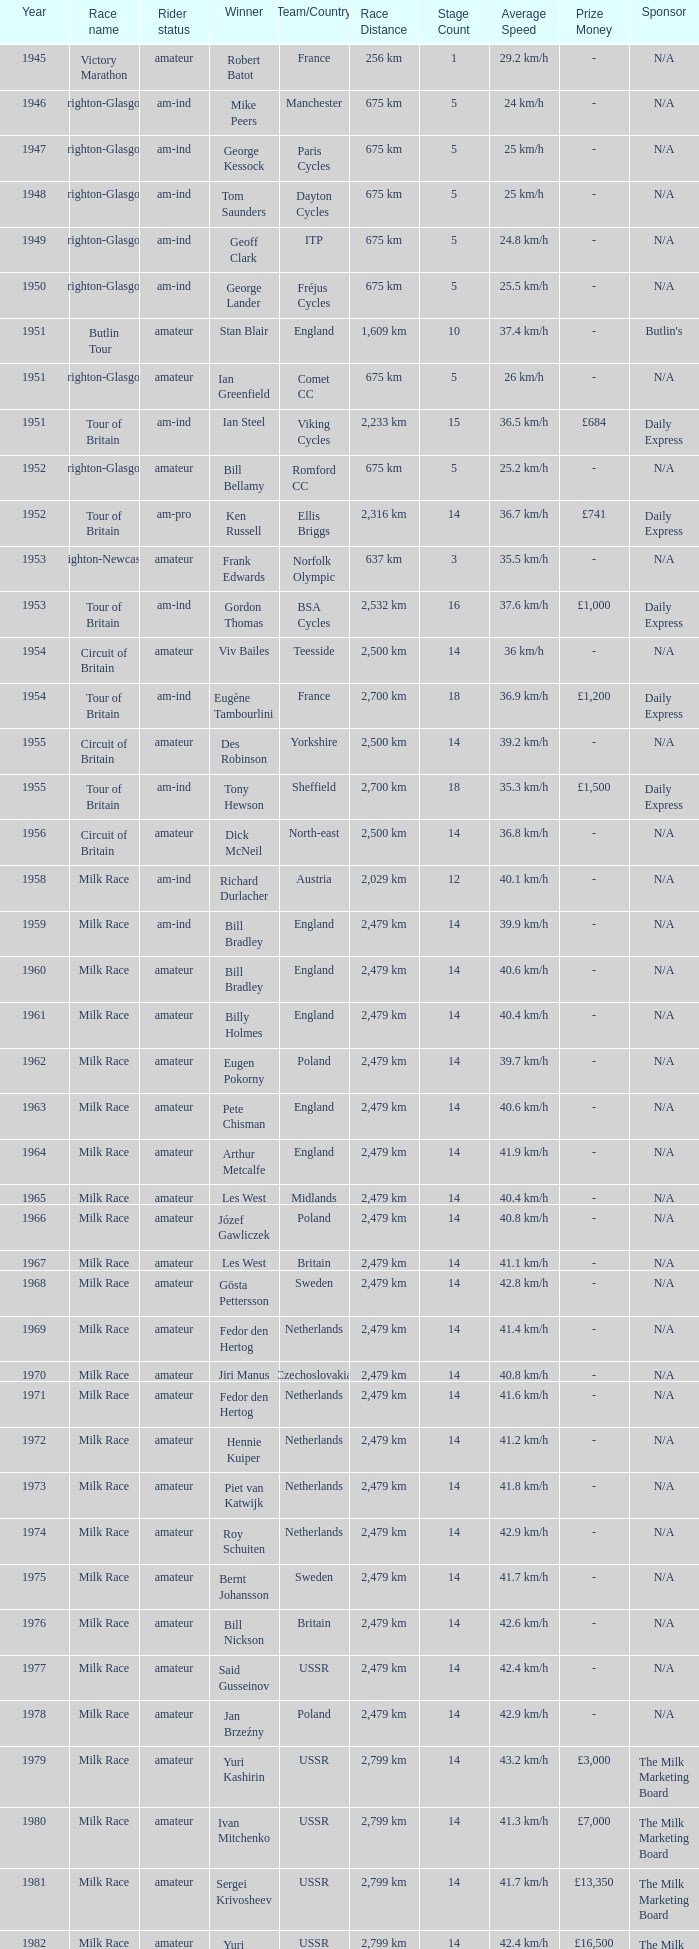What is the rider status for the 1971 netherlands team? Amateur. 